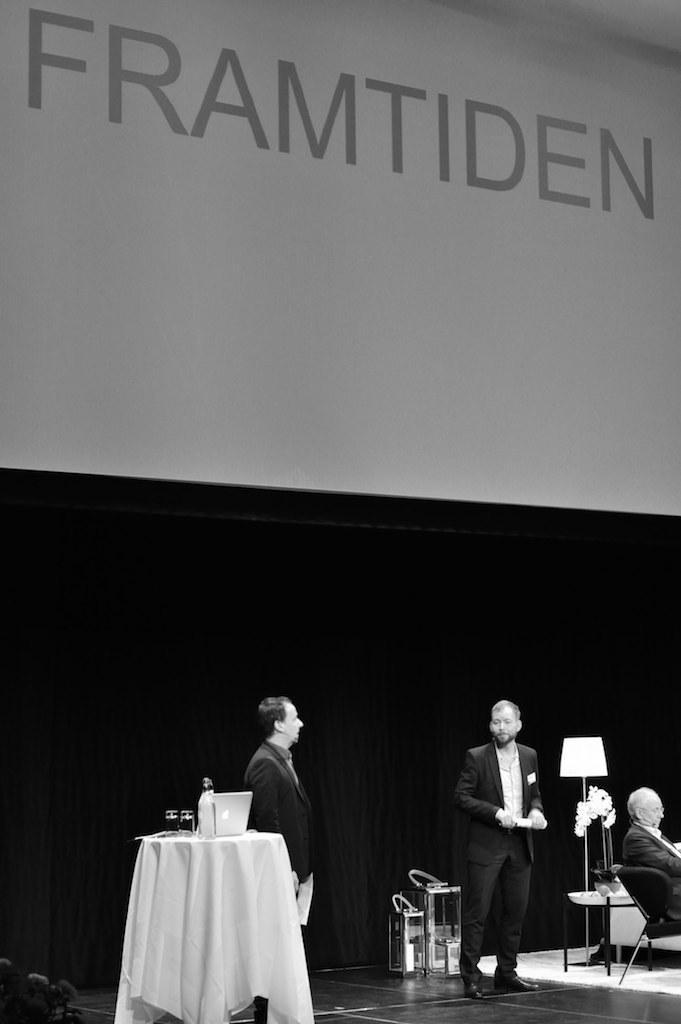Describe this image in one or two sentences. Two persons are standing,person sitting on the chair,on the table there is laptop and in the back there is poster. 